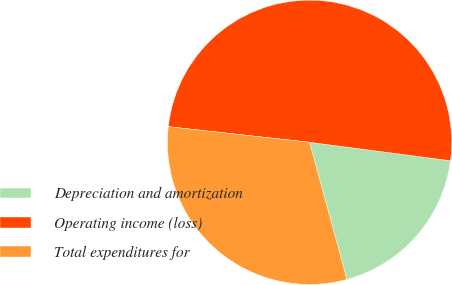Convert chart. <chart><loc_0><loc_0><loc_500><loc_500><pie_chart><fcel>Depreciation and amortization<fcel>Operating income (loss)<fcel>Total expenditures for<nl><fcel>18.69%<fcel>50.32%<fcel>30.99%<nl></chart> 